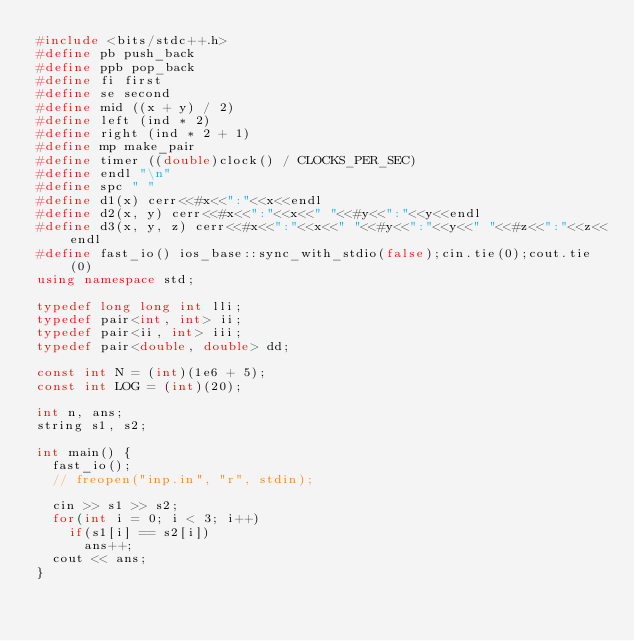<code> <loc_0><loc_0><loc_500><loc_500><_C++_>#include <bits/stdc++.h>
#define pb push_back
#define ppb pop_back
#define fi first
#define se second
#define mid ((x + y) / 2)
#define left (ind * 2)
#define right (ind * 2 + 1)
#define mp make_pair
#define timer ((double)clock() / CLOCKS_PER_SEC)
#define endl "\n"
#define spc " "
#define d1(x) cerr<<#x<<":"<<x<<endl
#define d2(x, y) cerr<<#x<<":"<<x<<" "<<#y<<":"<<y<<endl
#define d3(x, y, z) cerr<<#x<<":"<<x<<" "<<#y<<":"<<y<<" "<<#z<<":"<<z<<endl
#define fast_io() ios_base::sync_with_stdio(false);cin.tie(0);cout.tie(0)
using namespace std;

typedef long long int lli;
typedef pair<int, int> ii;
typedef pair<ii, int> iii;
typedef pair<double, double> dd;

const int N = (int)(1e6 + 5);
const int LOG = (int)(20);

int n, ans;
string s1, s2;

int main() {
	fast_io();
	// freopen("inp.in", "r", stdin);
	
	cin >> s1 >> s2;
	for(int i = 0; i < 3; i++)
		if(s1[i] == s2[i])
			ans++;
	cout << ans;
}</code> 